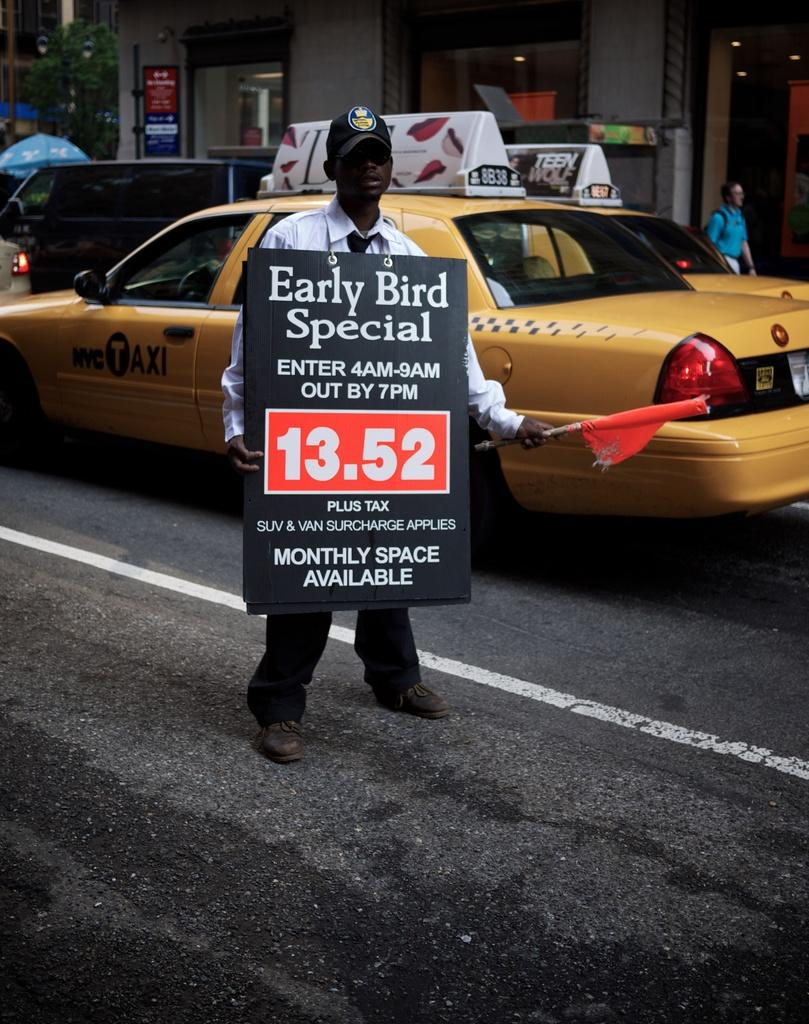<image>
Give a short and clear explanation of the subsequent image. A man is holding a sign that says Early Bird Special and waving an orange flag as Taxis drive by. 